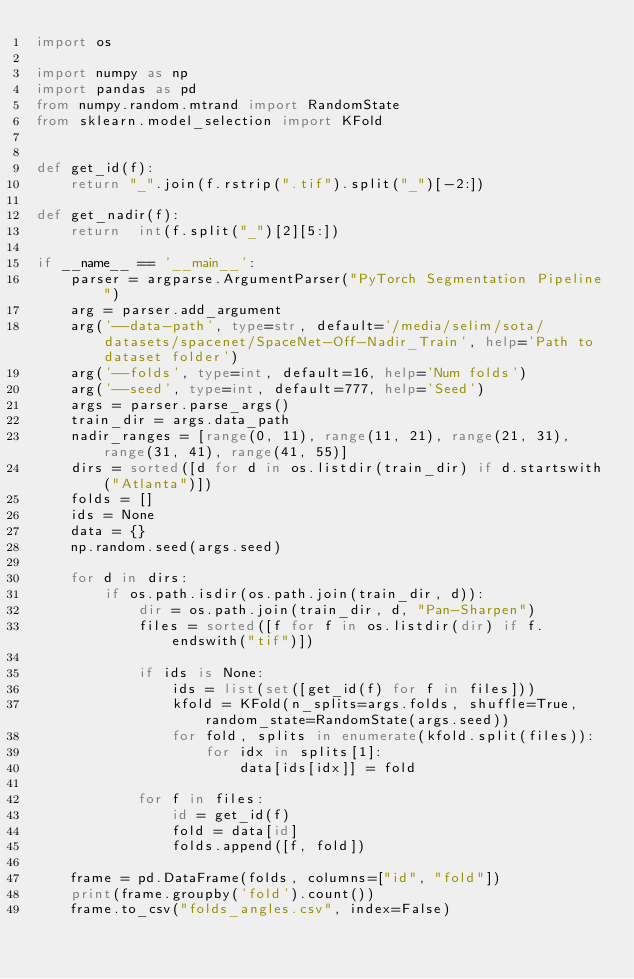Convert code to text. <code><loc_0><loc_0><loc_500><loc_500><_Python_>import os

import numpy as np
import pandas as pd
from numpy.random.mtrand import RandomState
from sklearn.model_selection import KFold


def get_id(f):
    return "_".join(f.rstrip(".tif").split("_")[-2:])

def get_nadir(f):
    return  int(f.split("_")[2][5:])

if __name__ == '__main__':
    parser = argparse.ArgumentParser("PyTorch Segmentation Pipeline")
    arg = parser.add_argument
    arg('--data-path', type=str, default='/media/selim/sota/datasets/spacenet/SpaceNet-Off-Nadir_Train', help='Path to dataset folder')
    arg('--folds', type=int, default=16, help='Num folds')
    arg('--seed', type=int, default=777, help='Seed')
    args = parser.parse_args()
    train_dir = args.data_path
    nadir_ranges = [range(0, 11), range(11, 21), range(21, 31), range(31, 41), range(41, 55)]
    dirs = sorted([d for d in os.listdir(train_dir) if d.startswith("Atlanta")])
    folds = []
    ids = None
    data = {}
    np.random.seed(args.seed)

    for d in dirs:
        if os.path.isdir(os.path.join(train_dir, d)):
            dir = os.path.join(train_dir, d, "Pan-Sharpen")
            files = sorted([f for f in os.listdir(dir) if f.endswith("tif")])

            if ids is None:
                ids = list(set([get_id(f) for f in files]))
                kfold = KFold(n_splits=args.folds, shuffle=True, random_state=RandomState(args.seed))
                for fold, splits in enumerate(kfold.split(files)):
                    for idx in splits[1]:
                        data[ids[idx]] = fold

            for f in files:
                id = get_id(f)
                fold = data[id]
                folds.append([f, fold])

    frame = pd.DataFrame(folds, columns=["id", "fold"])
    print(frame.groupby('fold').count())
    frame.to_csv("folds_angles.csv", index=False)

</code> 